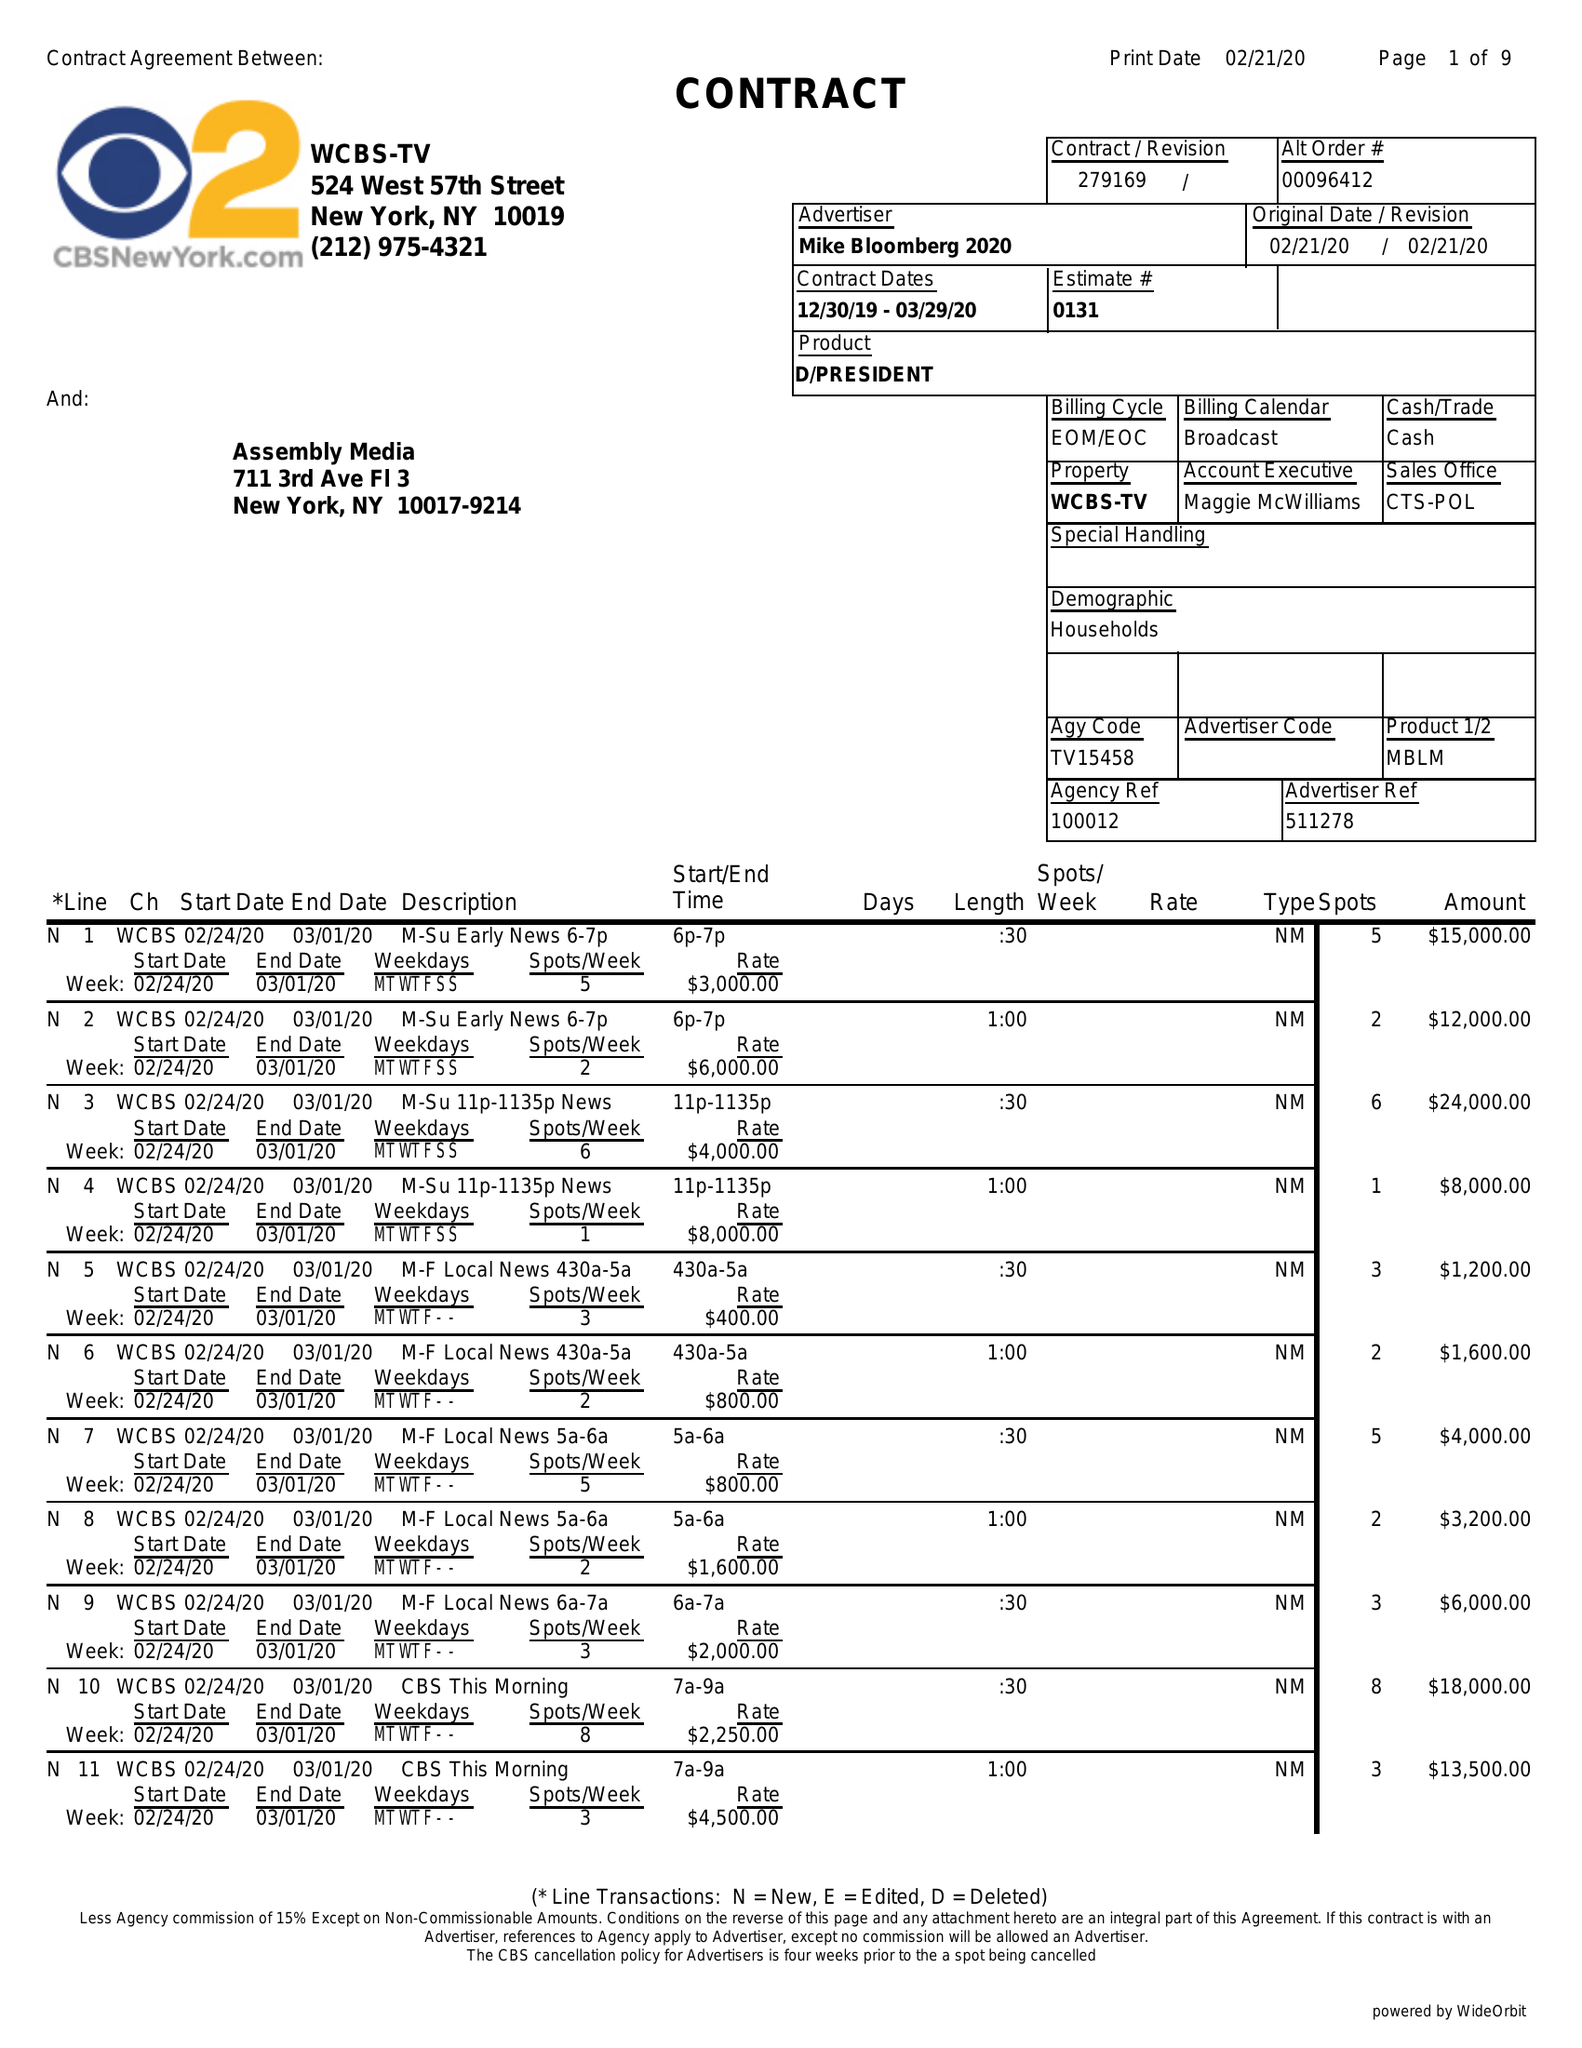What is the value for the contract_num?
Answer the question using a single word or phrase. 279169 